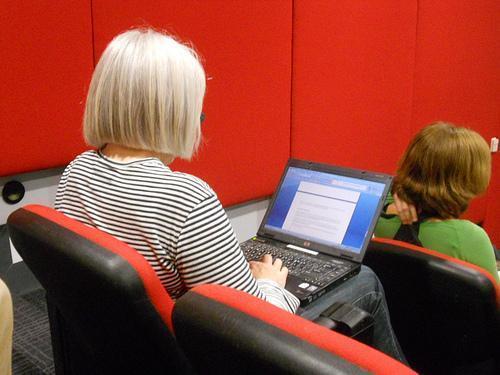How many people are visible?
Give a very brief answer. 2. How many people are pictured here?
Give a very brief answer. 2. How many people are wearing green?
Give a very brief answer. 1. How many people are shown?
Give a very brief answer. 2. 